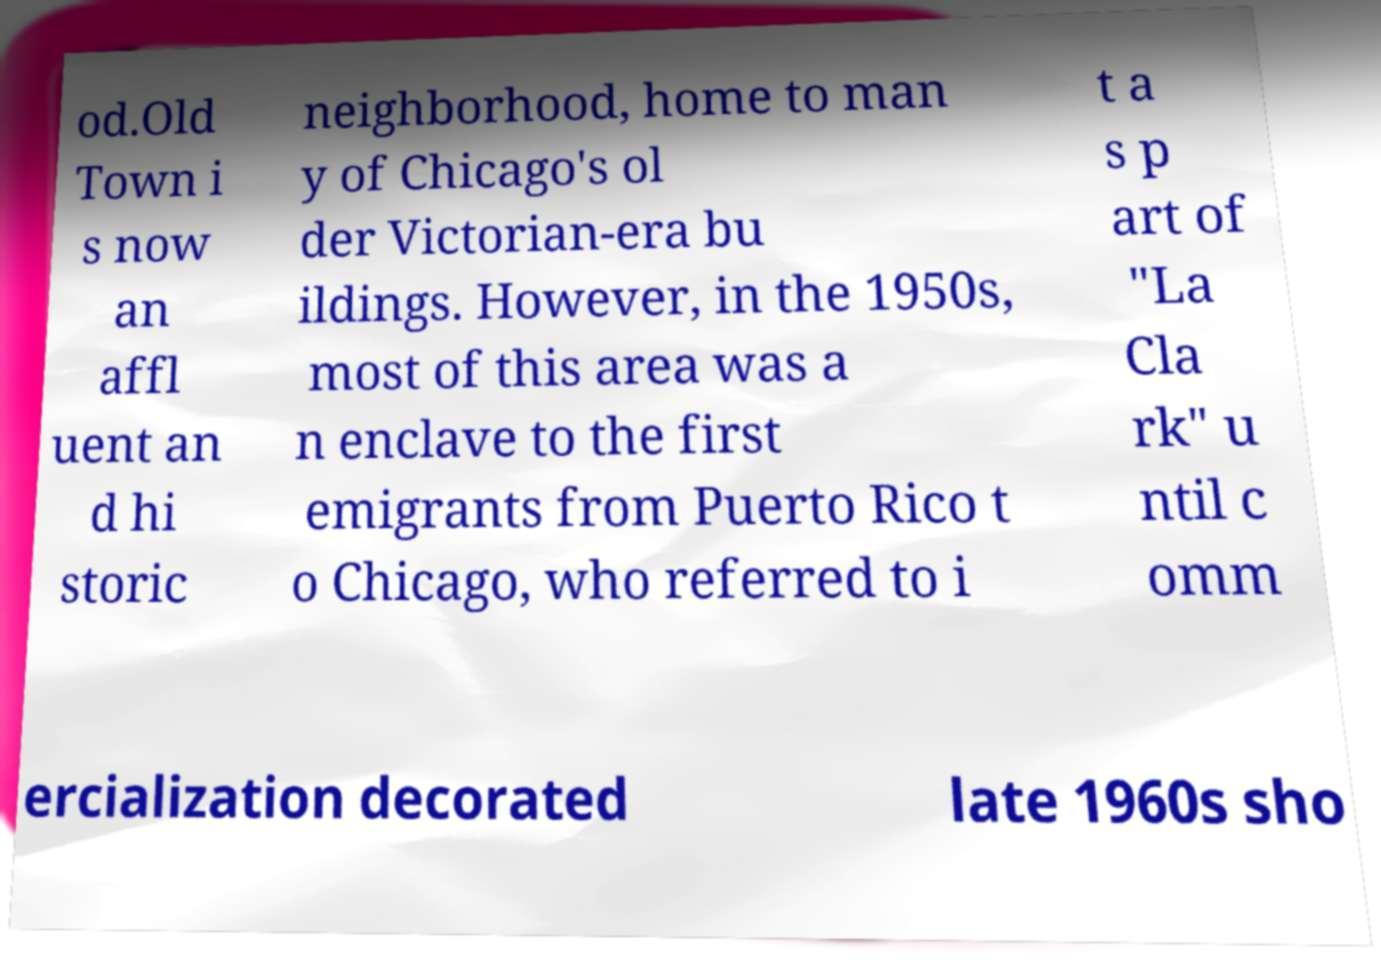What messages or text are displayed in this image? I need them in a readable, typed format. od.Old Town i s now an affl uent an d hi storic neighborhood, home to man y of Chicago's ol der Victorian-era bu ildings. However, in the 1950s, most of this area was a n enclave to the first emigrants from Puerto Rico t o Chicago, who referred to i t a s p art of "La Cla rk" u ntil c omm ercialization decorated late 1960s sho 